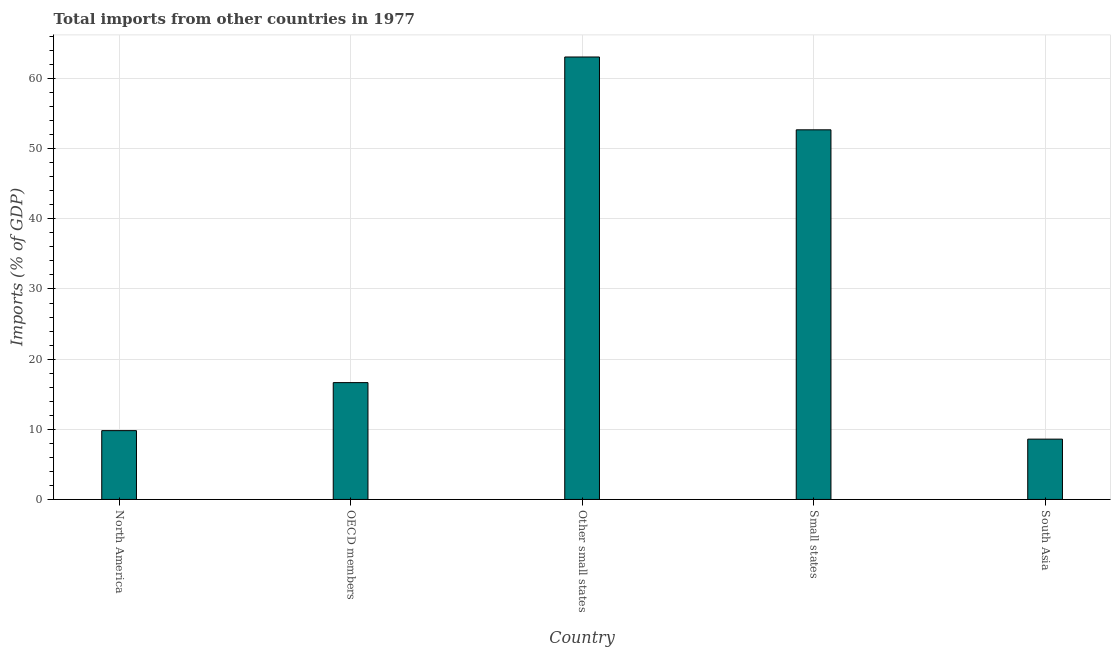Does the graph contain grids?
Your response must be concise. Yes. What is the title of the graph?
Offer a terse response. Total imports from other countries in 1977. What is the label or title of the X-axis?
Your answer should be compact. Country. What is the label or title of the Y-axis?
Provide a short and direct response. Imports (% of GDP). What is the total imports in Other small states?
Give a very brief answer. 63.07. Across all countries, what is the maximum total imports?
Provide a succinct answer. 63.07. Across all countries, what is the minimum total imports?
Provide a short and direct response. 8.6. In which country was the total imports maximum?
Your answer should be compact. Other small states. In which country was the total imports minimum?
Make the answer very short. South Asia. What is the sum of the total imports?
Offer a very short reply. 150.82. What is the difference between the total imports in North America and South Asia?
Provide a short and direct response. 1.21. What is the average total imports per country?
Provide a succinct answer. 30.16. What is the median total imports?
Ensure brevity in your answer.  16.65. In how many countries, is the total imports greater than 44 %?
Keep it short and to the point. 2. What is the ratio of the total imports in North America to that in OECD members?
Give a very brief answer. 0.59. Is the difference between the total imports in North America and South Asia greater than the difference between any two countries?
Your answer should be very brief. No. What is the difference between the highest and the second highest total imports?
Keep it short and to the point. 10.38. What is the difference between the highest and the lowest total imports?
Offer a very short reply. 54.47. How many bars are there?
Give a very brief answer. 5. Are all the bars in the graph horizontal?
Keep it short and to the point. No. How many countries are there in the graph?
Your answer should be very brief. 5. What is the Imports (% of GDP) in North America?
Your response must be concise. 9.81. What is the Imports (% of GDP) of OECD members?
Your answer should be compact. 16.65. What is the Imports (% of GDP) of Other small states?
Give a very brief answer. 63.07. What is the Imports (% of GDP) in Small states?
Provide a short and direct response. 52.69. What is the Imports (% of GDP) in South Asia?
Your response must be concise. 8.6. What is the difference between the Imports (% of GDP) in North America and OECD members?
Give a very brief answer. -6.84. What is the difference between the Imports (% of GDP) in North America and Other small states?
Give a very brief answer. -53.26. What is the difference between the Imports (% of GDP) in North America and Small states?
Ensure brevity in your answer.  -42.88. What is the difference between the Imports (% of GDP) in North America and South Asia?
Provide a succinct answer. 1.21. What is the difference between the Imports (% of GDP) in OECD members and Other small states?
Provide a short and direct response. -46.41. What is the difference between the Imports (% of GDP) in OECD members and Small states?
Offer a very short reply. -36.03. What is the difference between the Imports (% of GDP) in OECD members and South Asia?
Provide a short and direct response. 8.06. What is the difference between the Imports (% of GDP) in Other small states and Small states?
Give a very brief answer. 10.38. What is the difference between the Imports (% of GDP) in Other small states and South Asia?
Offer a terse response. 54.47. What is the difference between the Imports (% of GDP) in Small states and South Asia?
Your answer should be very brief. 44.09. What is the ratio of the Imports (% of GDP) in North America to that in OECD members?
Ensure brevity in your answer.  0.59. What is the ratio of the Imports (% of GDP) in North America to that in Other small states?
Your answer should be compact. 0.16. What is the ratio of the Imports (% of GDP) in North America to that in Small states?
Offer a terse response. 0.19. What is the ratio of the Imports (% of GDP) in North America to that in South Asia?
Provide a short and direct response. 1.14. What is the ratio of the Imports (% of GDP) in OECD members to that in Other small states?
Your answer should be compact. 0.26. What is the ratio of the Imports (% of GDP) in OECD members to that in Small states?
Keep it short and to the point. 0.32. What is the ratio of the Imports (% of GDP) in OECD members to that in South Asia?
Your answer should be compact. 1.94. What is the ratio of the Imports (% of GDP) in Other small states to that in Small states?
Offer a very short reply. 1.2. What is the ratio of the Imports (% of GDP) in Other small states to that in South Asia?
Provide a short and direct response. 7.34. What is the ratio of the Imports (% of GDP) in Small states to that in South Asia?
Ensure brevity in your answer.  6.13. 